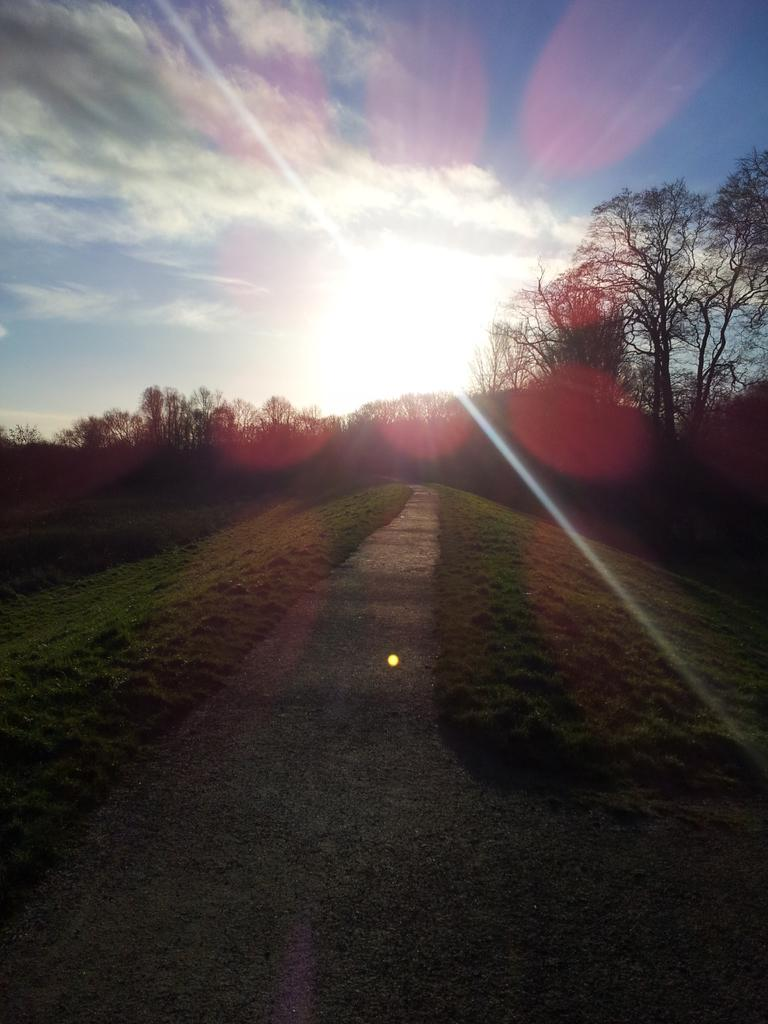What is the primary surface visible in the image? There is a ground in the image. What type of vegetation can be seen in the background of the image? There are trees in the background of the image. What is visible at the top of the image? The sky is visible at the top of the image. What is the weight of the tree in the image? The weight of the tree cannot be determined from the image, as it does not provide any information about the size or density of the tree. 